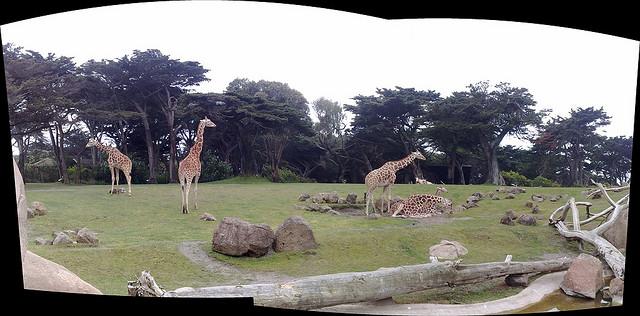Are these animals at the zoo?
Keep it brief. Yes. How many animals are in the picture?
Write a very short answer. 4. Is this looking through a vehicle window?
Write a very short answer. Yes. 